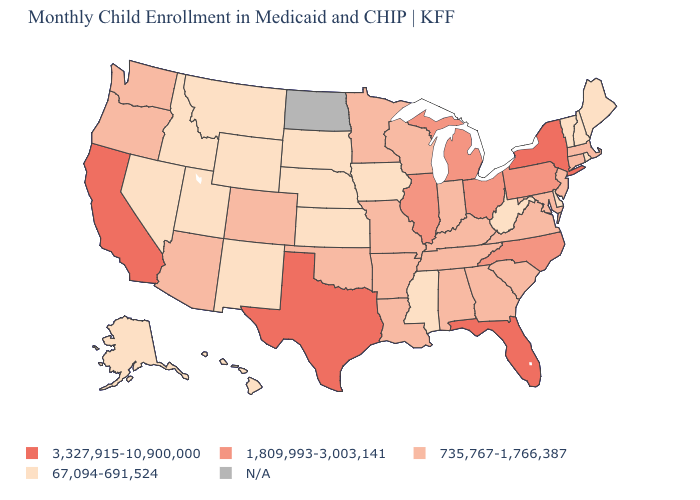Among the states that border New Mexico , does Utah have the lowest value?
Write a very short answer. Yes. What is the value of Florida?
Keep it brief. 3,327,915-10,900,000. What is the value of Nebraska?
Be succinct. 67,094-691,524. How many symbols are there in the legend?
Write a very short answer. 5. Which states have the lowest value in the USA?
Quick response, please. Alaska, Delaware, Hawaii, Idaho, Iowa, Kansas, Maine, Mississippi, Montana, Nebraska, Nevada, New Hampshire, New Mexico, Rhode Island, South Dakota, Utah, Vermont, West Virginia, Wyoming. What is the highest value in states that border Minnesota?
Short answer required. 735,767-1,766,387. Name the states that have a value in the range 735,767-1,766,387?
Quick response, please. Alabama, Arizona, Arkansas, Colorado, Connecticut, Georgia, Indiana, Kentucky, Louisiana, Maryland, Massachusetts, Minnesota, Missouri, New Jersey, Oklahoma, Oregon, South Carolina, Tennessee, Virginia, Washington, Wisconsin. Does the first symbol in the legend represent the smallest category?
Quick response, please. No. Which states have the lowest value in the USA?
Short answer required. Alaska, Delaware, Hawaii, Idaho, Iowa, Kansas, Maine, Mississippi, Montana, Nebraska, Nevada, New Hampshire, New Mexico, Rhode Island, South Dakota, Utah, Vermont, West Virginia, Wyoming. Does Michigan have the highest value in the USA?
Quick response, please. No. How many symbols are there in the legend?
Be succinct. 5. Among the states that border Maryland , which have the lowest value?
Concise answer only. Delaware, West Virginia. Name the states that have a value in the range 1,809,993-3,003,141?
Be succinct. Illinois, Michigan, North Carolina, Ohio, Pennsylvania. Which states have the lowest value in the USA?
Be succinct. Alaska, Delaware, Hawaii, Idaho, Iowa, Kansas, Maine, Mississippi, Montana, Nebraska, Nevada, New Hampshire, New Mexico, Rhode Island, South Dakota, Utah, Vermont, West Virginia, Wyoming. 